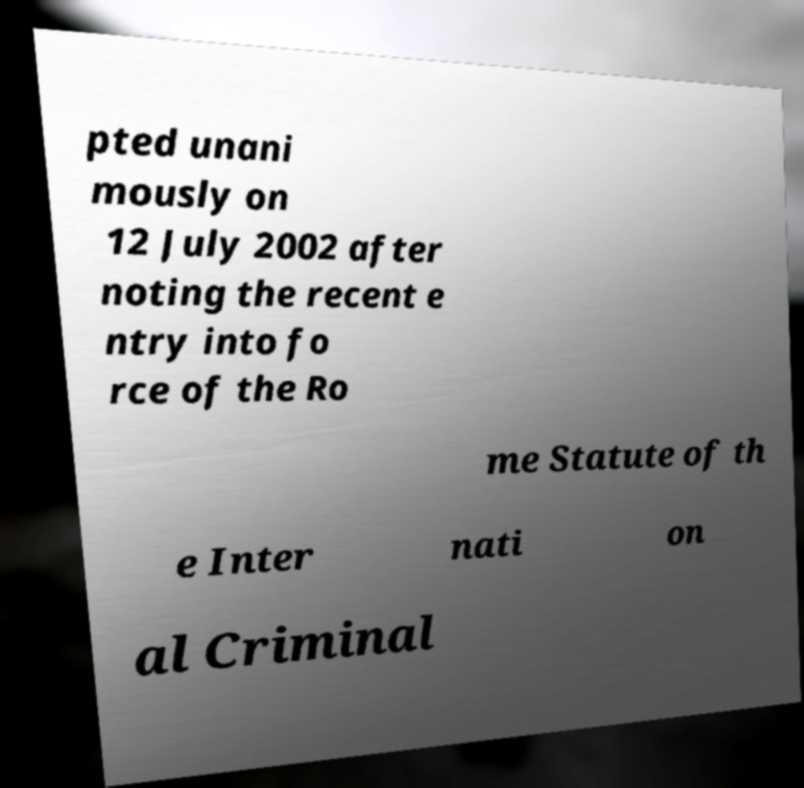I need the written content from this picture converted into text. Can you do that? pted unani mously on 12 July 2002 after noting the recent e ntry into fo rce of the Ro me Statute of th e Inter nati on al Criminal 